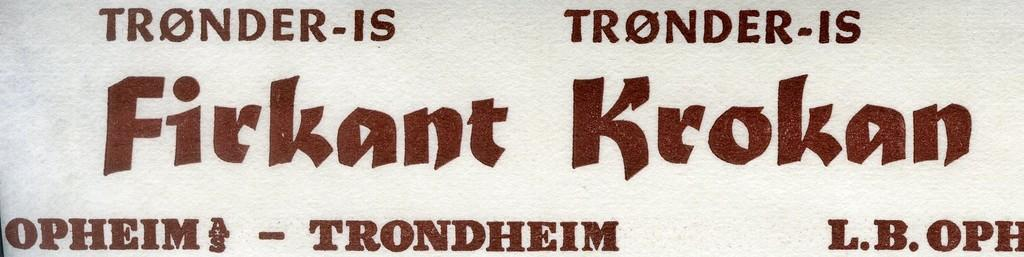<image>
Provide a brief description of the given image. A flyer for Firkant Krokan that says tronder-is on top. 